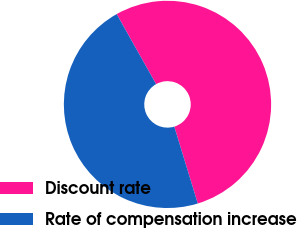Convert chart. <chart><loc_0><loc_0><loc_500><loc_500><pie_chart><fcel>Discount rate<fcel>Rate of compensation increase<nl><fcel>53.44%<fcel>46.56%<nl></chart> 